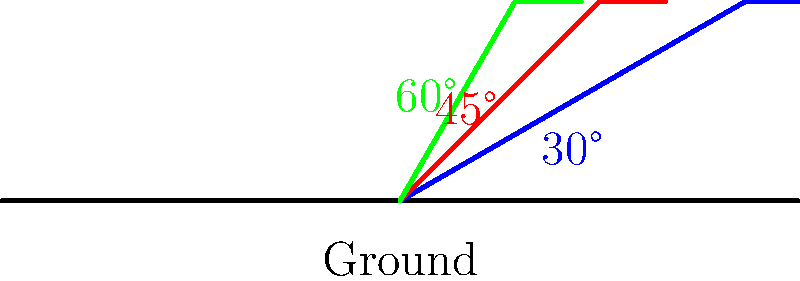Which skateboard ramp angle shown in the diagram is considered the safest for beginners and provides the best balance between challenge and safety? To determine the safest ramp angle for beginners, we need to consider the following factors:

1. Steepness: Steeper ramps are more challenging and potentially dangerous for beginners.
2. Speed: Steeper ramps generate higher speeds, which can be harder to control.
3. Landing impact: Steeper ramps result in harder landings, increasing the risk of injury.
4. Skill development: A ramp that's too easy may not help in skill progression.

Let's analyze each angle:

1. 60° ramp (green):
   - Very steep and challenging
   - Generates high speeds
   - Hard landings
   - Not suitable for beginners

2. 45° ramp (red):
   - Moderately steep
   - Moderate speeds
   - Moderate landing impact
   - Challenging but manageable for intermediate riders

3. 30° ramp (blue):
   - Gentler slope
   - Lower speeds
   - Softer landings
   - Easier to control and learn basic techniques

The 30° ramp provides the best balance between safety and skill development for beginners. It allows new skaters to:
- Build confidence gradually
- Learn proper technique with less risk
- Experience softer landings, reducing injury risk
- Develop skills needed for steeper ramps in the future

While the 45° ramp might be suitable for more experienced beginners, the 30° ramp is the safest option for those just starting out in skateboarding.
Answer: 30° ramp 